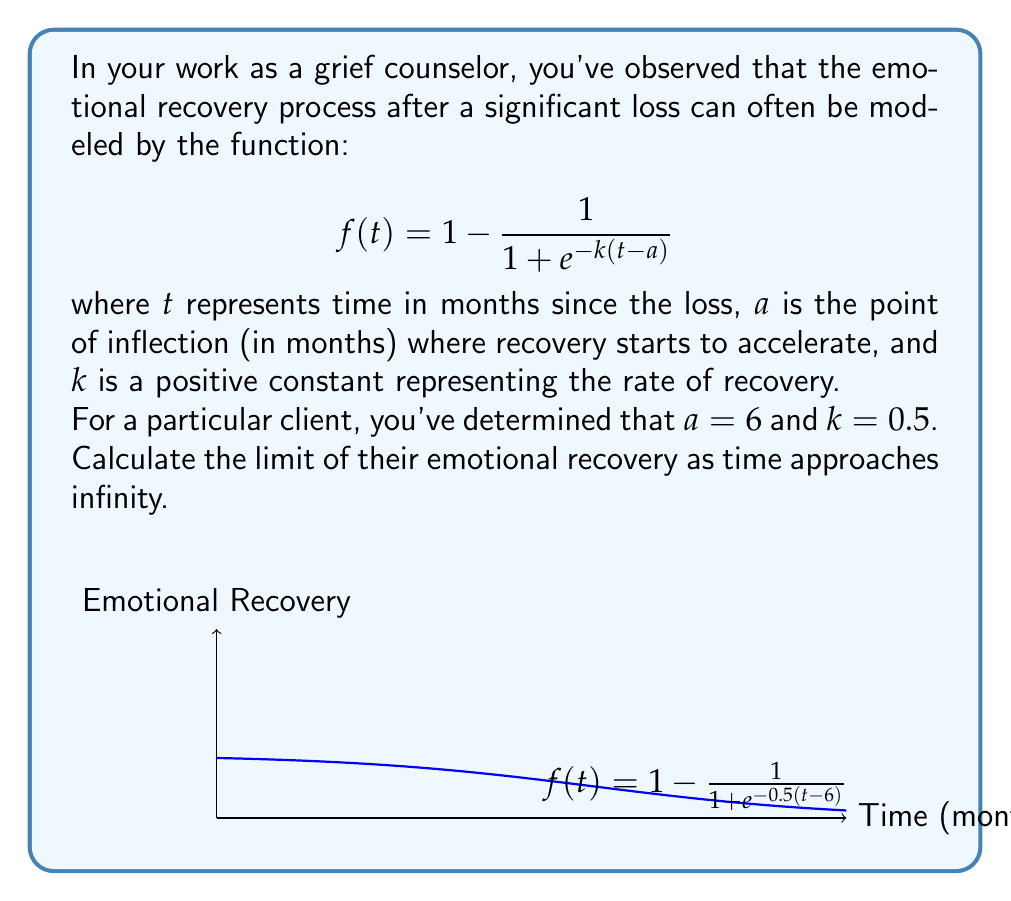Teach me how to tackle this problem. To find the limit of the function as time approaches infinity, we'll follow these steps:

1) The given function is:
   $$f(t) = 1 - \frac{1}{1 + e^{-k(t-a)}}$$
   with $k = 0.5$ and $a = 6$

2) We need to calculate:
   $$\lim_{t \to \infty} f(t) = \lim_{t \to \infty} \left(1 - \frac{1}{1 + e^{-0.5(t-6)}}\right)$$

3) As $t$ approaches infinity, the exponent $-0.5(t-6)$ will approach negative infinity:
   $$\lim_{t \to \infty} -0.5(t-6) = -\infty$$

4) Therefore:
   $$\lim_{t \to \infty} e^{-0.5(t-6)} = e^{-\infty} = 0$$

5) This means:
   $$\lim_{t \to \infty} (1 + e^{-0.5(t-6)}) = 1 + 0 = 1$$

6) Substituting this back into our original function:
   $$\lim_{t \to \infty} f(t) = \lim_{t \to \infty} \left(1 - \frac{1}{1 + e^{-0.5(t-6)}}\right) = 1 - \frac{1}{1} = 1 - 1 = 0$$

7) Therefore, the limit of the emotional recovery function as time approaches infinity is 1.

This result suggests that, according to this model, the client's emotional state will approach complete recovery (represented by 1) as time goes on indefinitely.
Answer: $1$ 